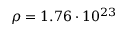<formula> <loc_0><loc_0><loc_500><loc_500>\rho = 1 . 7 6 \cdot 1 0 ^ { 2 3 }</formula> 